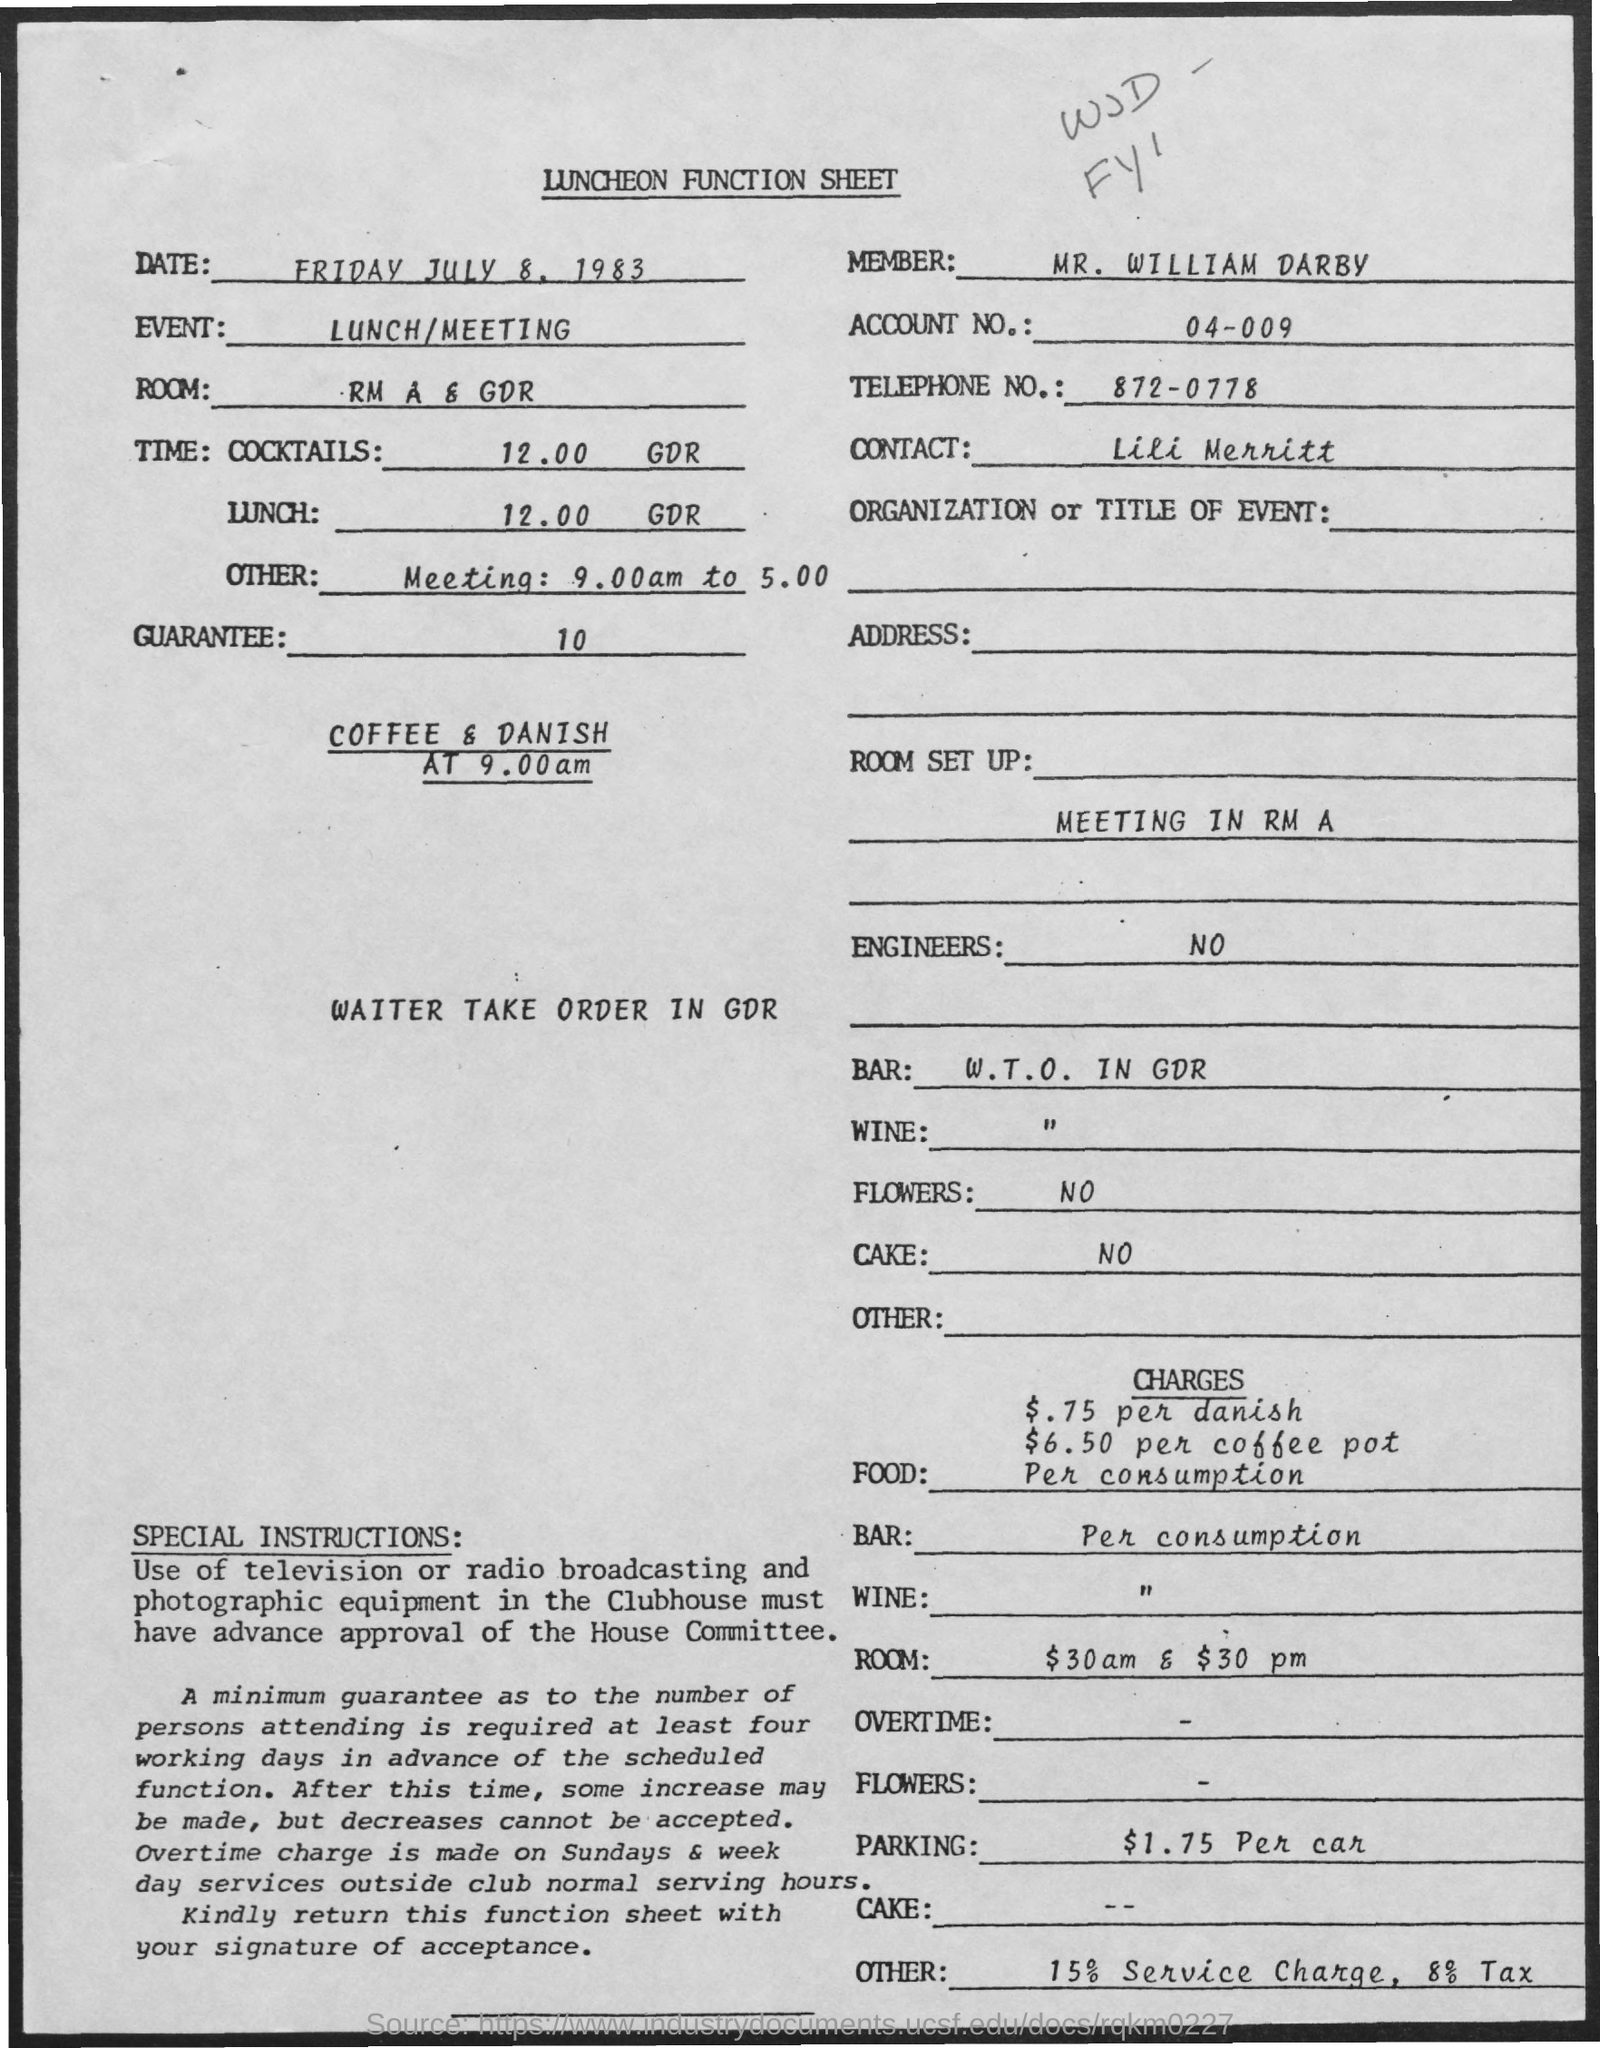Point out several critical features in this image. The member mentioned in this document is MR. WILLIAM DARBY. The telephone number provided in this document is 872-0778. The charge for parking is $1.75 per car, as stated in the document. The account number mentioned in this document is 04-009. The event mentioned in this document is lunch/meeting. 